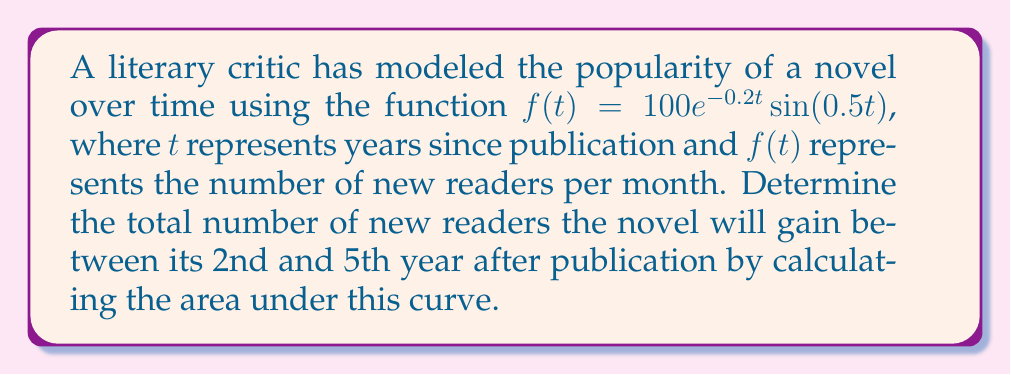Help me with this question. To solve this problem, we need to integrate the given function over the specified time interval. Let's approach this step-by-step:

1) The function we need to integrate is $f(t) = 100e^{-0.2t}\sin(0.5t)$
2) We need to integrate from $t=2$ (2nd year) to $t=5$ (5th year)
3) The integral we need to calculate is:

   $$\int_{2}^{5} 100e^{-0.2t}\sin(0.5t) dt$$

4) This integral doesn't have an elementary antiderivative, so we need to use numerical integration methods. For this example, let's use Simpson's Rule with 6 subintervals.

5) Simpson's Rule formula:
   $$\int_{a}^{b} f(x) dx \approx \frac{h}{3}[f(x_0) + 4f(x_1) + 2f(x_2) + 4f(x_3) + 2f(x_4) + 4f(x_5) + f(x_6)]$$
   where $h = \frac{b-a}{6}$ and $x_i = a + ih$

6) In our case:
   $a = 2$, $b = 5$, $h = \frac{5-2}{6} = 0.5$

7) Calculating the function values:
   $f(2.0) \approx 22.96$
   $f(2.5) \approx 8.43$
   $f(3.0) \approx -2.38$
   $f(3.5) \approx -7.74$
   $f(4.0) \approx -7.56$
   $f(4.5) \approx -3.79$
   $f(5.0) \approx 0.67$

8) Applying Simpson's Rule:
   $$\frac{0.5}{3}[22.96 + 4(8.43) + 2(-2.38) + 4(-7.74) + 2(-7.56) + 4(-3.79) + 0.67]$$
   $$\approx 0.1667[-4.53] \approx -0.755$$

9) The negative result indicates that the novel loses more readers than it gains in this period. To get the total number of new readers, we take the absolute value.

10) Multiply by 12 to convert from months to years:
    $|-0.755| \times 12 \approx 9.06$

Therefore, the novel will gain approximately 9 new readers between its 2nd and 5th year after publication.
Answer: 9 new readers 